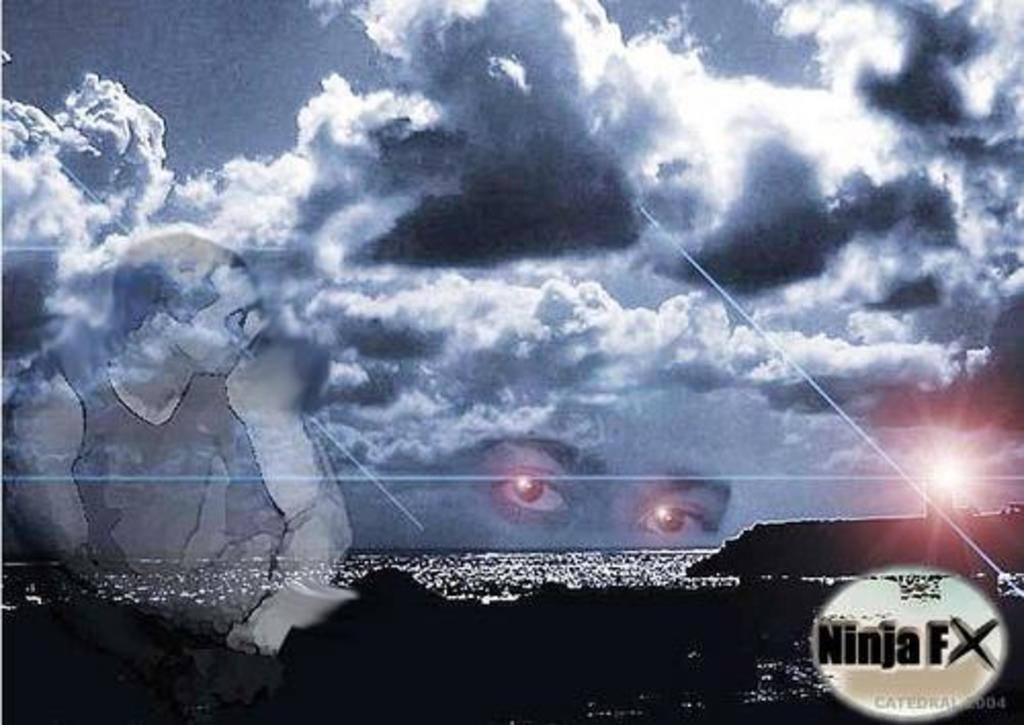What natural feature is depicted in the image? There is the sea in the image. What celestial body is visible in the image? The sun is visible in the image. Can you describe the person in the image? There is a person in the image, and their eyes are visible. What additional information is provided on the image? There is text on the image. What atmospheric conditions can be observed in the image? Clouds are present in the image. What else is visible in the image besides the sea and the person? The sky is visible in the image. What is the person in the image pointing at during the battle? There is no battle depicted in the image, and the person is not pointing at anything. 